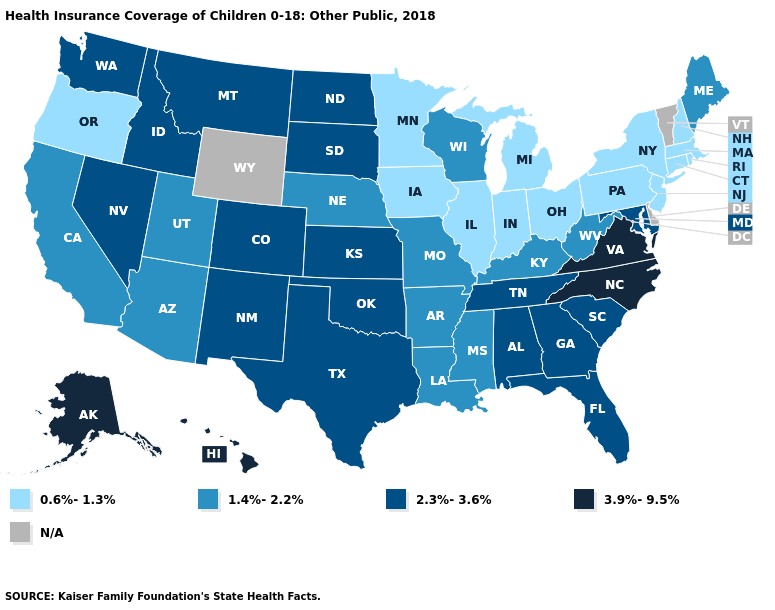Among the states that border Mississippi , which have the highest value?
Short answer required. Alabama, Tennessee. Among the states that border Texas , which have the highest value?
Short answer required. New Mexico, Oklahoma. Which states hav the highest value in the South?
Quick response, please. North Carolina, Virginia. Name the states that have a value in the range 1.4%-2.2%?
Quick response, please. Arizona, Arkansas, California, Kentucky, Louisiana, Maine, Mississippi, Missouri, Nebraska, Utah, West Virginia, Wisconsin. What is the value of Texas?
Quick response, please. 2.3%-3.6%. What is the lowest value in states that border New Mexico?
Be succinct. 1.4%-2.2%. Name the states that have a value in the range N/A?
Give a very brief answer. Delaware, Vermont, Wyoming. What is the value of Rhode Island?
Write a very short answer. 0.6%-1.3%. Name the states that have a value in the range N/A?
Quick response, please. Delaware, Vermont, Wyoming. Name the states that have a value in the range 1.4%-2.2%?
Concise answer only. Arizona, Arkansas, California, Kentucky, Louisiana, Maine, Mississippi, Missouri, Nebraska, Utah, West Virginia, Wisconsin. What is the value of Minnesota?
Write a very short answer. 0.6%-1.3%. What is the value of New York?
Quick response, please. 0.6%-1.3%. Among the states that border Michigan , does Wisconsin have the lowest value?
Quick response, please. No. 